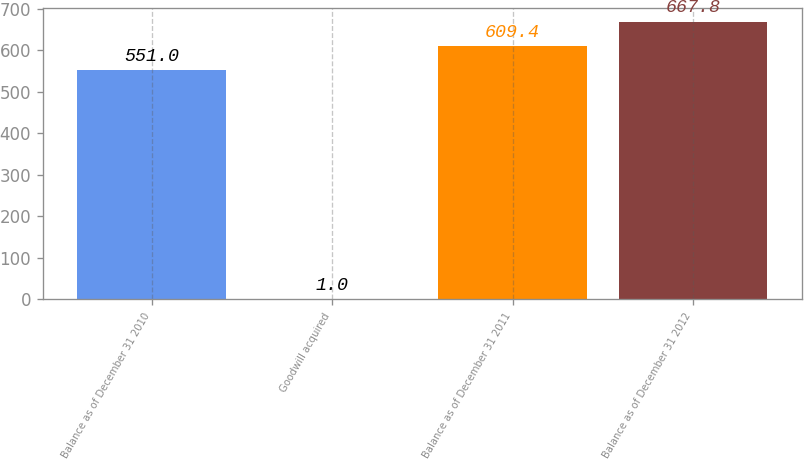<chart> <loc_0><loc_0><loc_500><loc_500><bar_chart><fcel>Balance as of December 31 2010<fcel>Goodwill acquired<fcel>Balance as of December 31 2011<fcel>Balance as of December 31 2012<nl><fcel>551<fcel>1<fcel>609.4<fcel>667.8<nl></chart> 